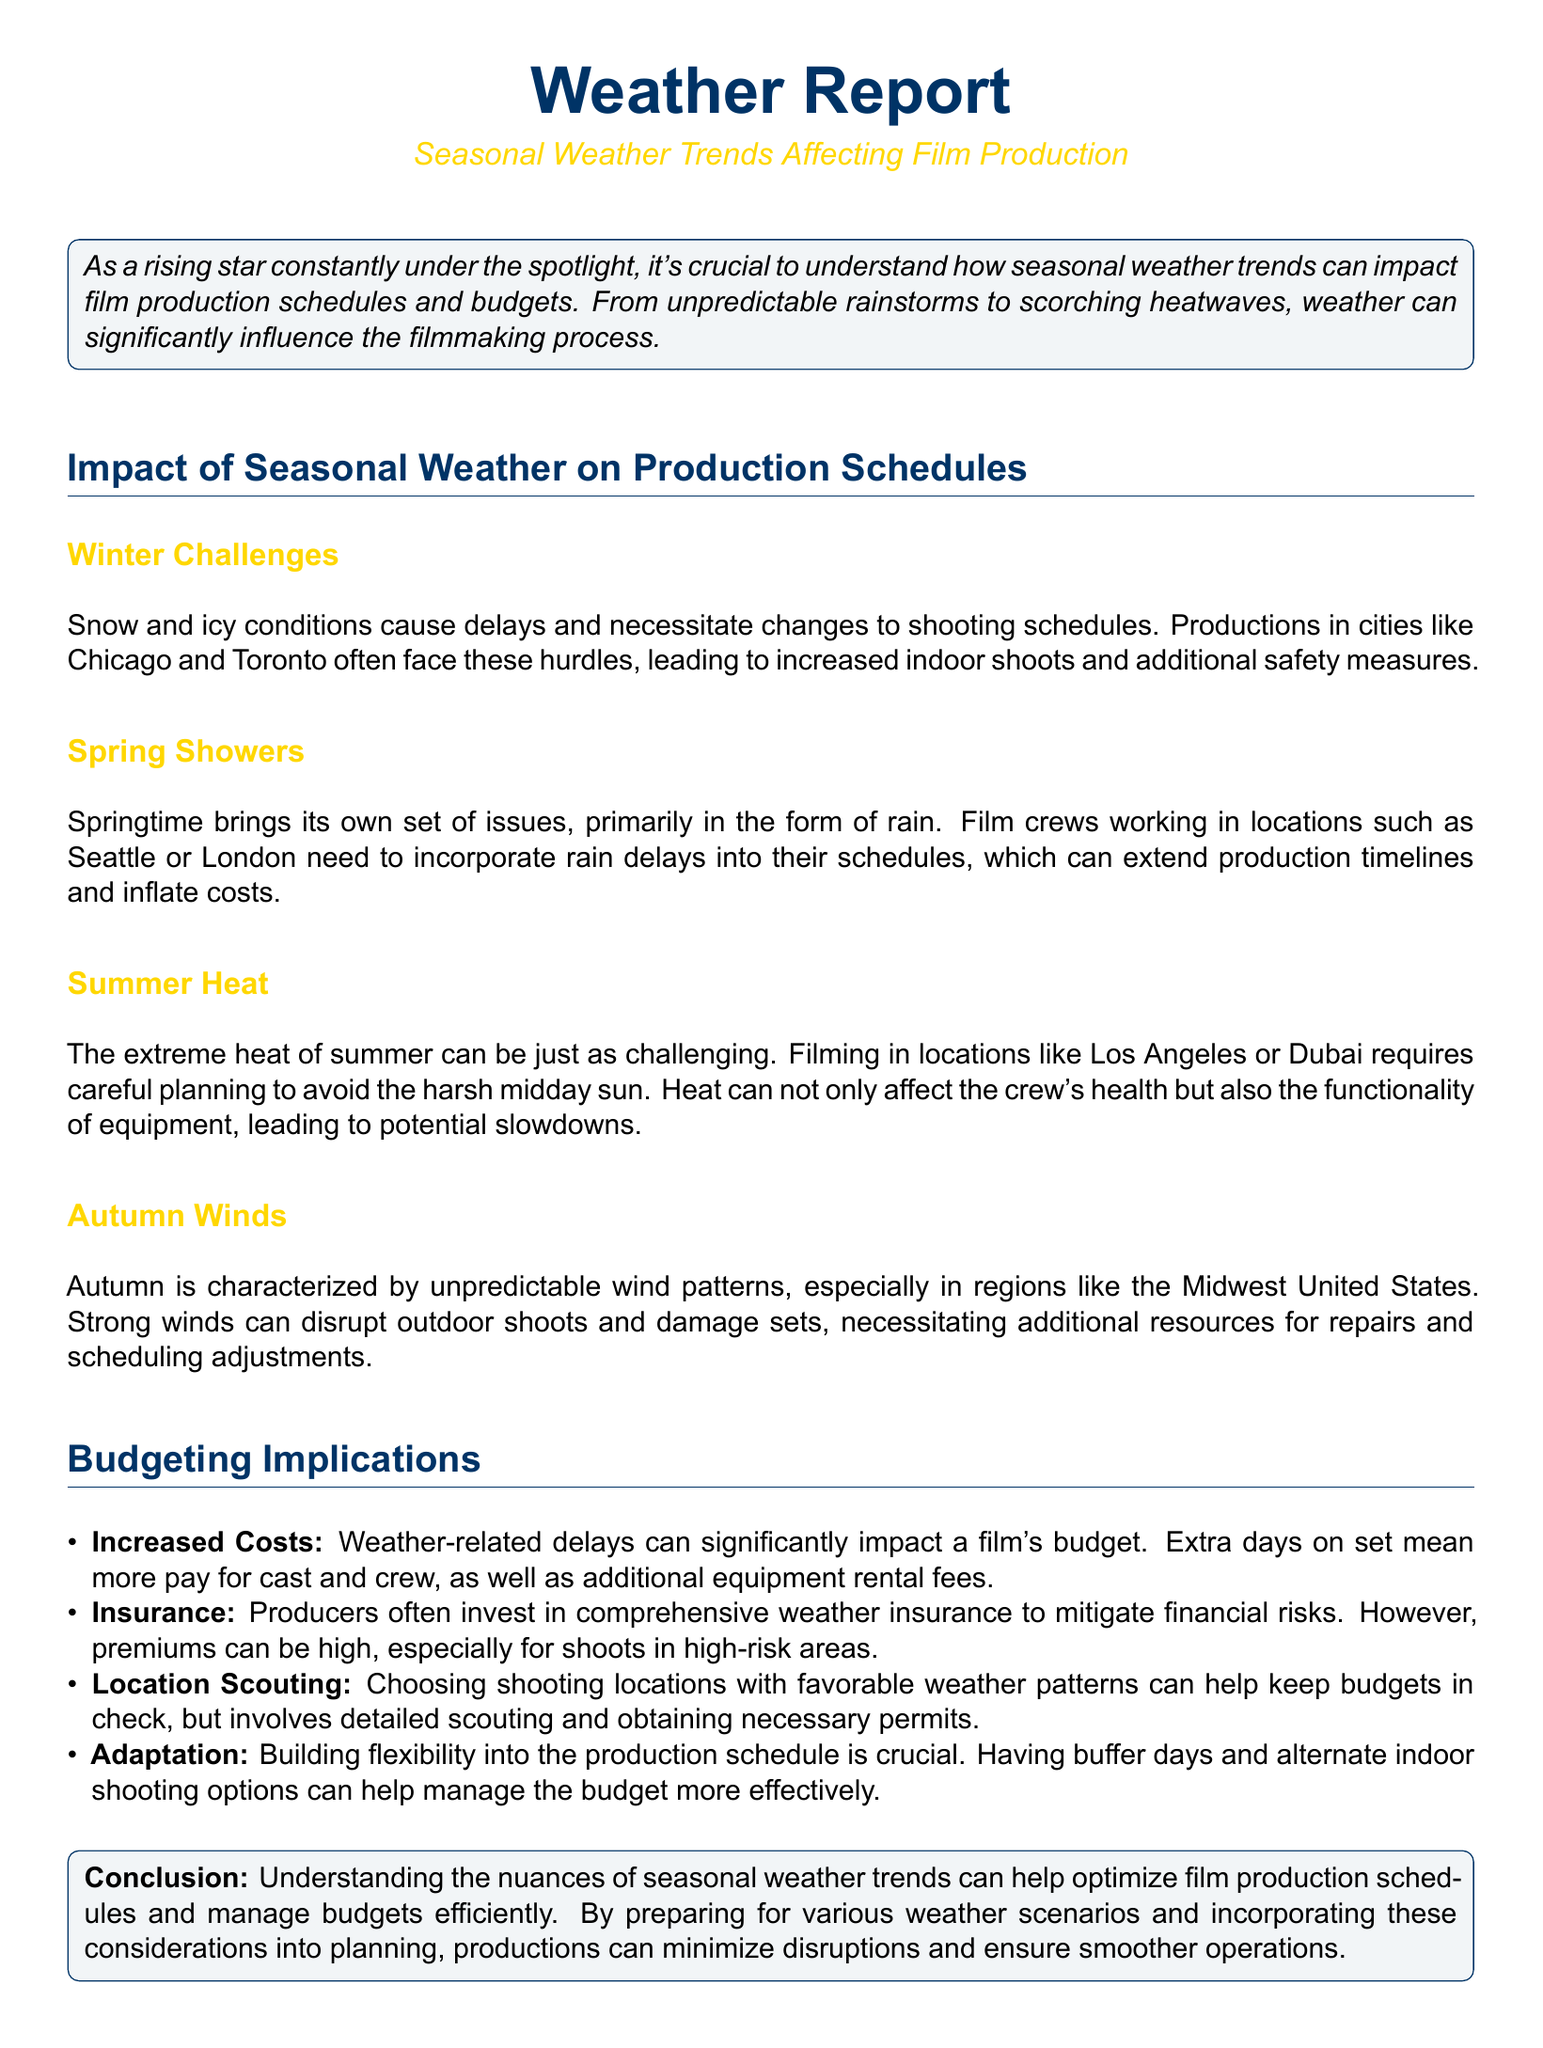What are the winter challenges in film production? The winter challenges include snow and icy conditions that cause delays and necessitate changes to shooting schedules.
Answer: Snow and icy conditions What is a significant issue during spring? Springtime brings rain, which requires film crews to incorporate rain delays into their schedules.
Answer: Rain Which location is mentioned as facing challenges due to summer heat? Filming in Los Angeles or Dubai requires careful planning to avoid the harsh midday sun.
Answer: Los Angeles or Dubai What can budget overruns during production be attributed to? Weather-related delays can significantly impact a film's budget, leading to extra days on set and additional costs.
Answer: Weather-related delays What type of insurance do producers often invest in? Producers often invest in comprehensive weather insurance to mitigate financial risks.
Answer: Weather insurance What helps keep budgets in check regarding locations? Choosing shooting locations with favorable weather patterns can help keep budgets in check.
Answer: Favorable weather patterns What is crucial for managing production schedules according to the document? Building flexibility into the production schedule, having buffer days and alternate indoor options is crucial.
Answer: Flexibility What characterizes autumn weather patterns mentioned? Autumn is characterized by unpredictable wind patterns, particularly in the Midwest United States.
Answer: Unpredictable wind patterns What is emphasized as a conclusion in the report? Understanding the nuances of seasonal weather trends can help optimize film production and manage budgets.
Answer: Understanding nuances of seasonal weather trends 